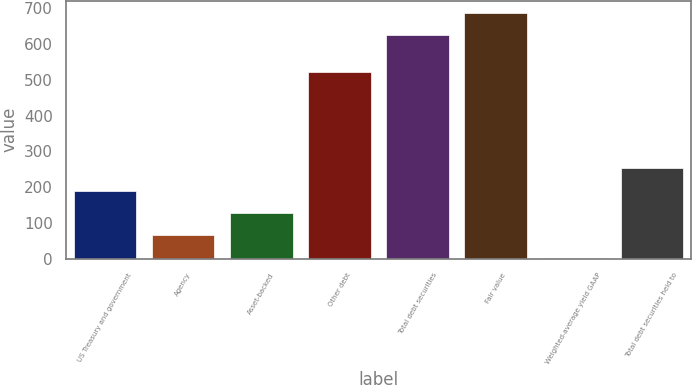Convert chart. <chart><loc_0><loc_0><loc_500><loc_500><bar_chart><fcel>US Treasury and government<fcel>Agency<fcel>Asset-backed<fcel>Other debt<fcel>Total debt securities<fcel>Fair value<fcel>Weighted-average yield GAAP<fcel>Total debt securities held to<nl><fcel>189.72<fcel>65.06<fcel>127.39<fcel>521<fcel>624<fcel>686.33<fcel>2.73<fcel>252.05<nl></chart> 